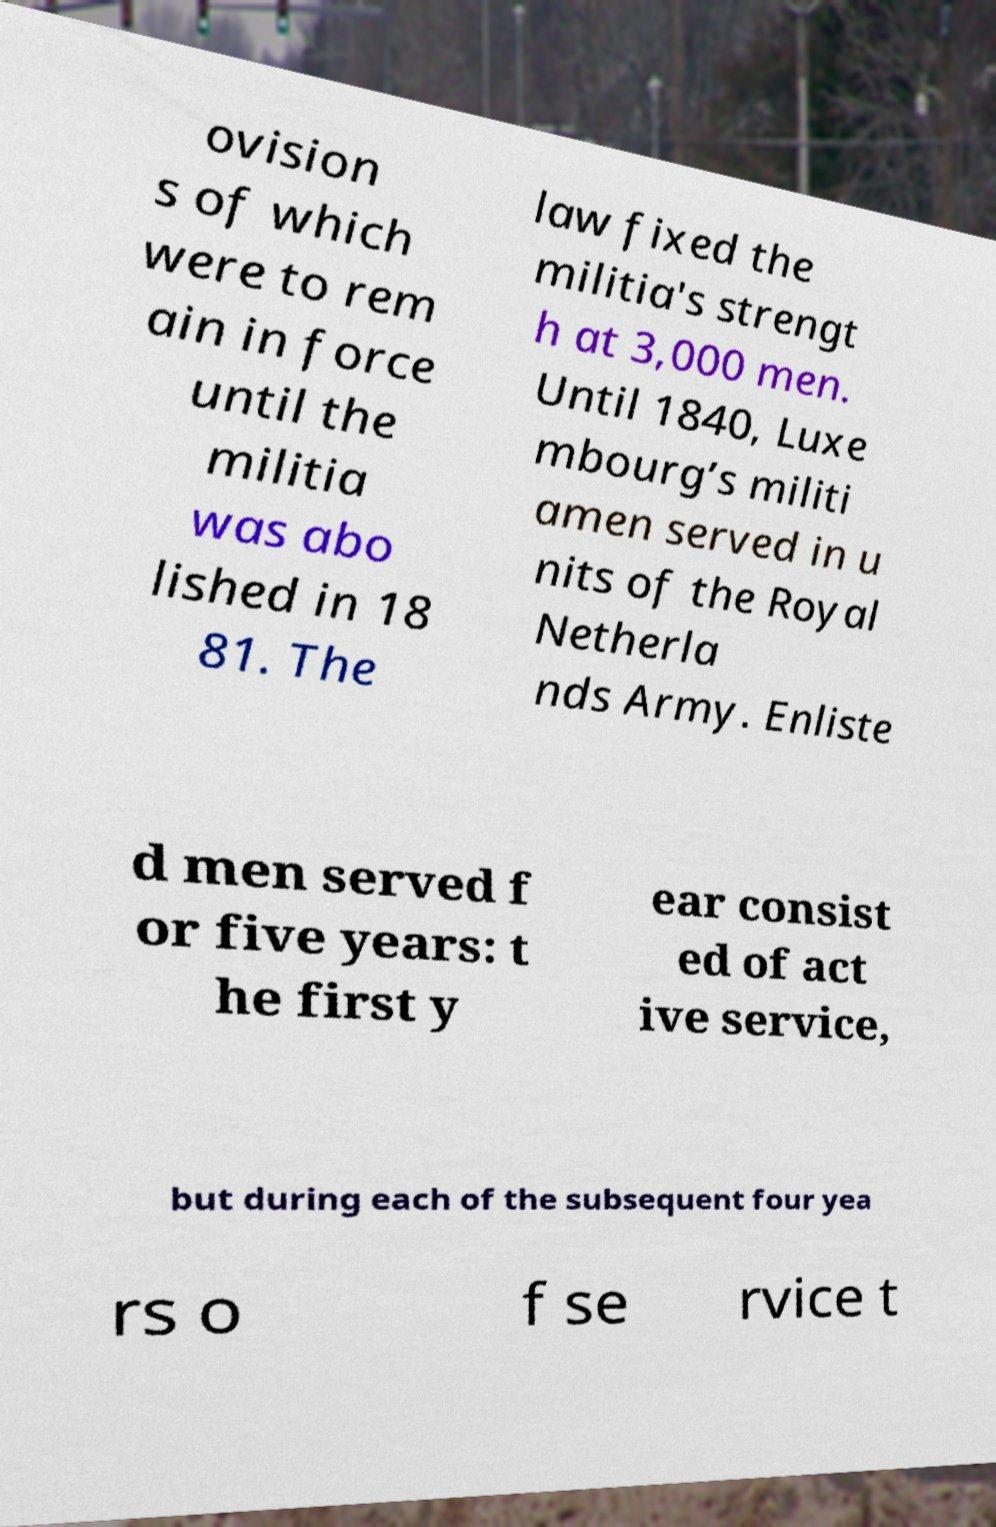Could you assist in decoding the text presented in this image and type it out clearly? ovision s of which were to rem ain in force until the militia was abo lished in 18 81. The law fixed the militia's strengt h at 3,000 men. Until 1840, Luxe mbourg’s militi amen served in u nits of the Royal Netherla nds Army. Enliste d men served f or five years: t he first y ear consist ed of act ive service, but during each of the subsequent four yea rs o f se rvice t 